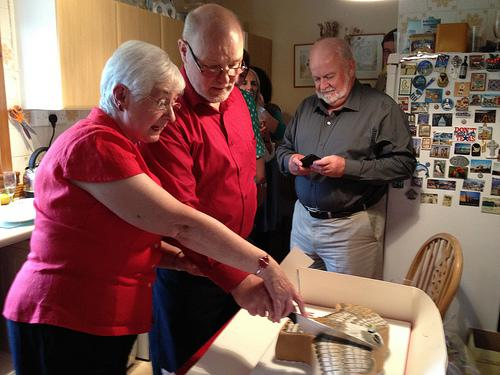Question: where are these people?
Choices:
A. Bathroom.
B. Dining Room.
C. Living Room.
D. Kitchen.
Answer with the letter. Answer: D Question: what is the man in gray looking at?
Choices:
A. His phone.
B. The sky.
C. The ground.
D. The bench.
Answer with the letter. Answer: A Question: what are the people in red doing?
Choices:
A. Cutting a cake.
B. Eating.
C. Sleeping.
D. Running.
Answer with the letter. Answer: A Question: what are they using to cut the cake?
Choices:
A. A knife.
B. Silverware.
C. Their hands.
D. A fork.
Answer with the letter. Answer: A 